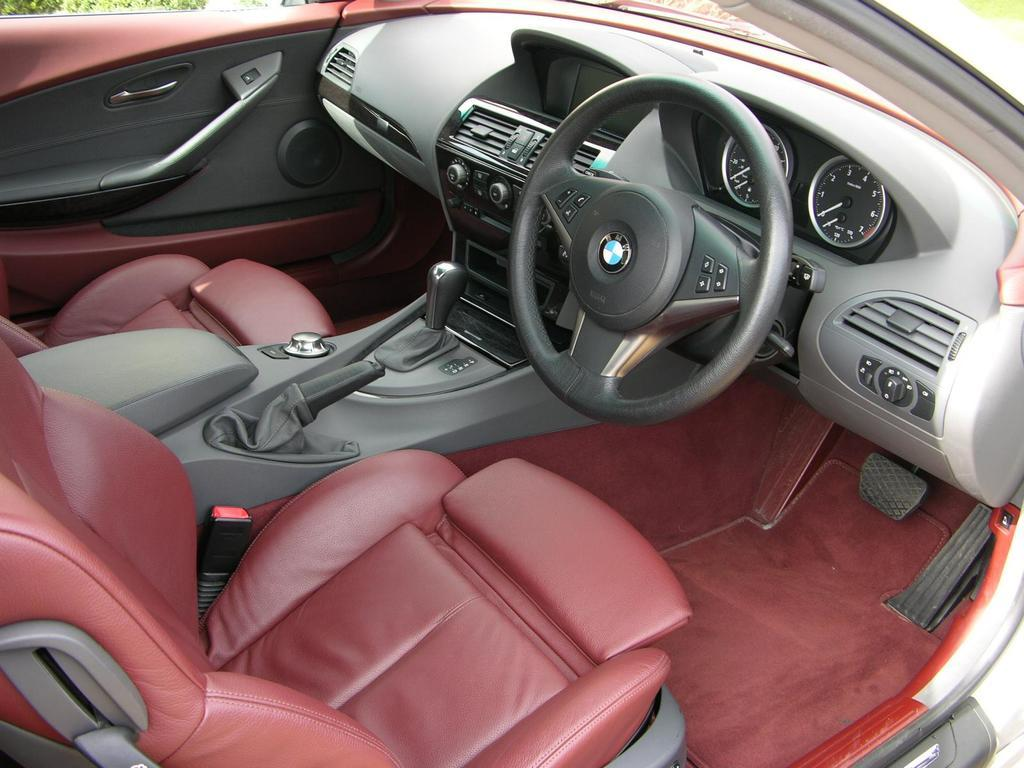What type of vehicle is shown in the image? The image is an inside view of a car. What can be found inside the car? There are seats, a gear rod, a steering wheel, a deck, and meters visible in the car. How many chairs are placed around the deck in the image? There are no chairs or deck present in the image; it is an inside view of a car. 